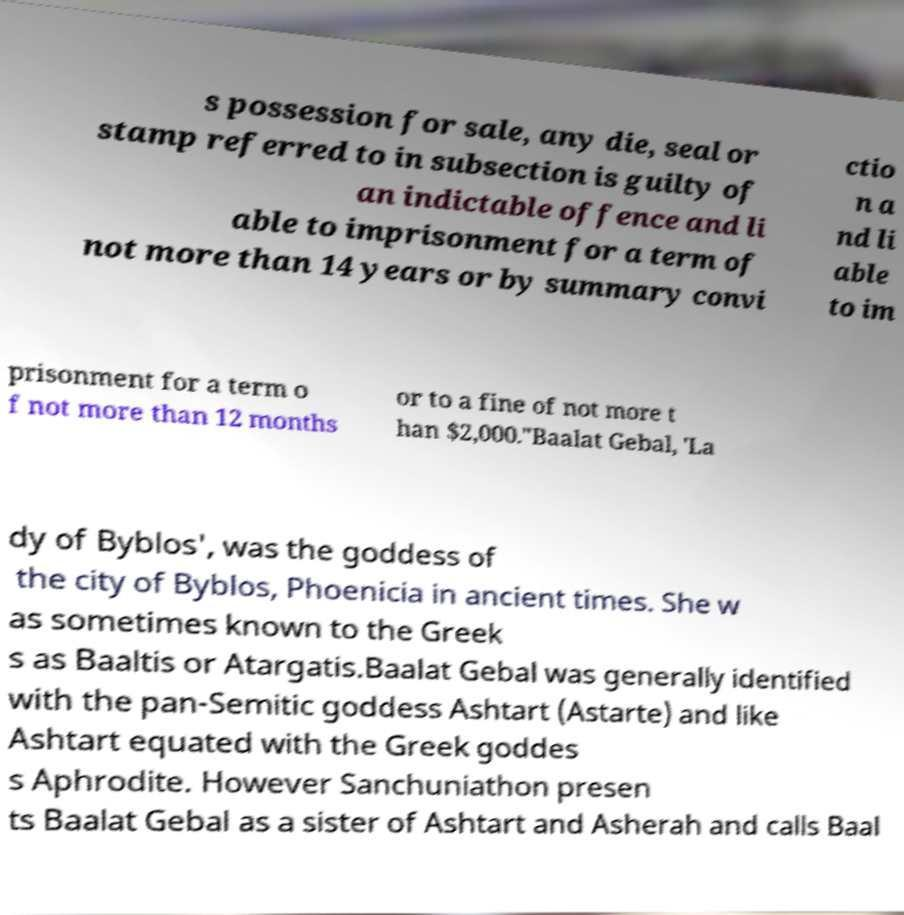Could you assist in decoding the text presented in this image and type it out clearly? s possession for sale, any die, seal or stamp referred to in subsection is guilty of an indictable offence and li able to imprisonment for a term of not more than 14 years or by summary convi ctio n a nd li able to im prisonment for a term o f not more than 12 months or to a fine of not more t han $2,000."Baalat Gebal, 'La dy of Byblos', was the goddess of the city of Byblos, Phoenicia in ancient times. She w as sometimes known to the Greek s as Baaltis or Atargatis.Baalat Gebal was generally identified with the pan-Semitic goddess Ashtart (Astarte) and like Ashtart equated with the Greek goddes s Aphrodite. However Sanchuniathon presen ts Baalat Gebal as a sister of Ashtart and Asherah and calls Baal 